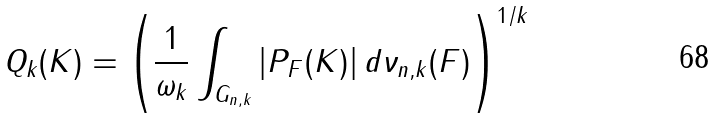Convert formula to latex. <formula><loc_0><loc_0><loc_500><loc_500>Q _ { k } ( K ) = \left ( \frac { 1 } { \omega _ { k } } \int _ { G _ { n , k } } | P _ { F } ( K ) | \, d \nu _ { n , k } ( F ) \right ) ^ { 1 / k }</formula> 